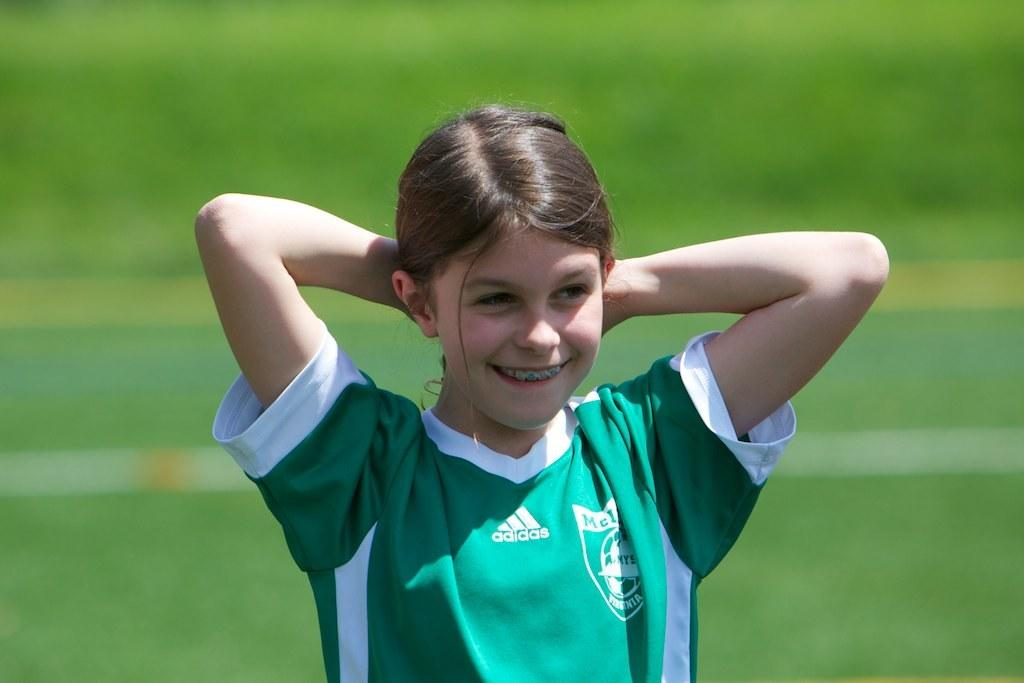<image>
Give a short and clear explanation of the subsequent image. A young girl in a soccer uniform that says adidas has her hands behind her head. 